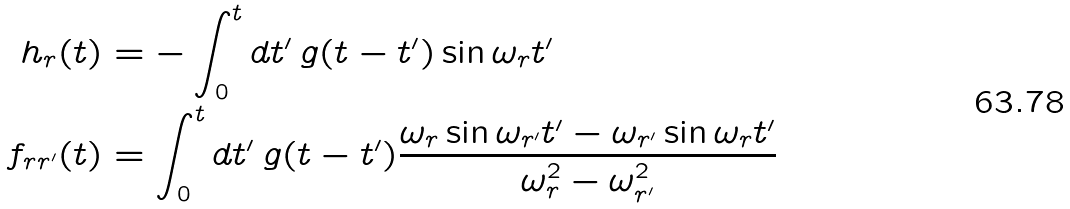Convert formula to latex. <formula><loc_0><loc_0><loc_500><loc_500>h _ { r } ( t ) & = - \int _ { 0 } ^ { t } d t ^ { \prime } \, g ( t - t ^ { \prime } ) \sin \omega _ { r } t ^ { \prime } \\ f _ { r r ^ { \prime } } ( t ) & = \int _ { 0 } ^ { t } d t ^ { \prime } \, g ( t - t ^ { \prime } ) \frac { \omega _ { r } \sin \omega _ { r ^ { \prime } } t ^ { \prime } - \omega _ { r ^ { \prime } } \sin \omega _ { r } t ^ { \prime } } { \omega _ { r } ^ { 2 } - \omega _ { r ^ { \prime } } ^ { 2 } }</formula> 